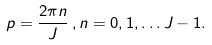<formula> <loc_0><loc_0><loc_500><loc_500>p & = \frac { 2 \pi n } { J } \, , n = 0 , 1 , \dots J - 1 .</formula> 